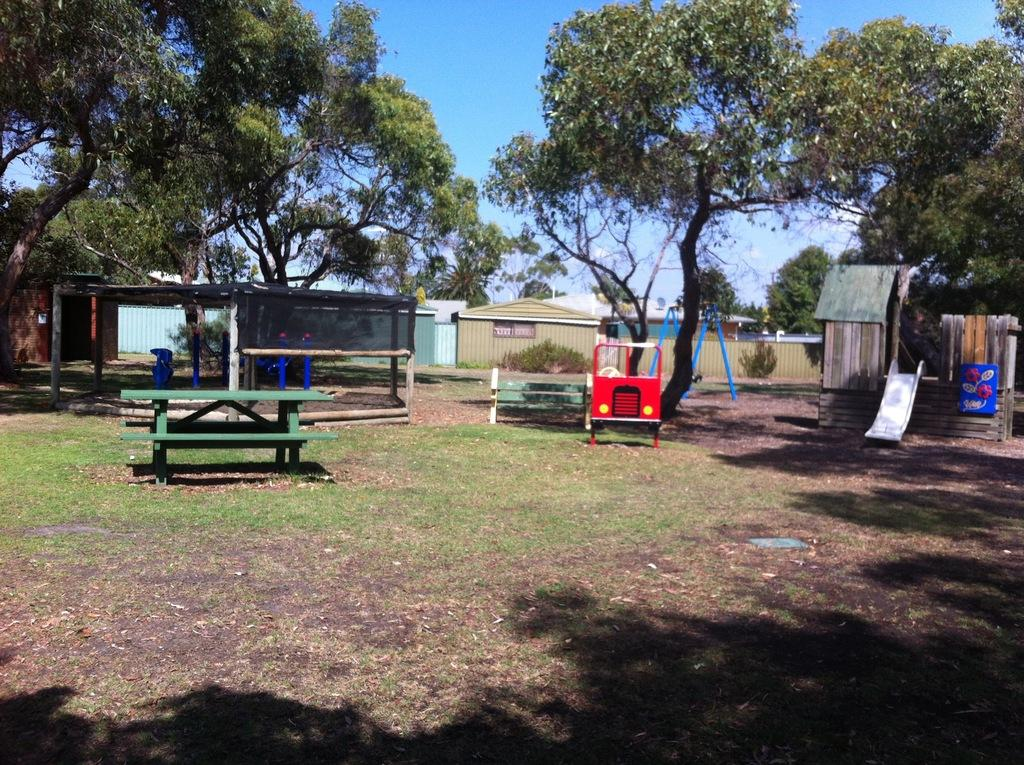What type of seating is available in the image? There are benches in the image. What type of playground equipment can be seen in the image? There is a U-shaped swing, a kids' playing car, and a slider in the image. What type of vegetation is present in the image? There are plants in the image. What type of structures are visible in the image? There are buildings and a shed in the image. What can be seen in the background of the image? There are trees and sky visible in the background of the image. What type of animal is framing the image? There is no animal present in the image, and the concept of an animal framing the image is not applicable. 